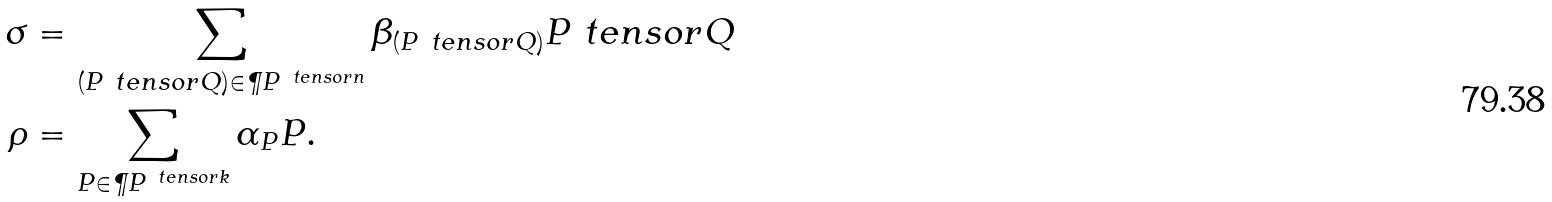<formula> <loc_0><loc_0><loc_500><loc_500>\sigma & = \sum _ { ( P \ t e n s o r Q ) \in \P P ^ { \ t e n s o r n } } \beta _ { ( P \ t e n s o r Q ) } P \ t e n s o r Q \\ \rho & = \sum _ { P \in \P P ^ { \ t e n s o r k } } \alpha _ { P } P .</formula> 